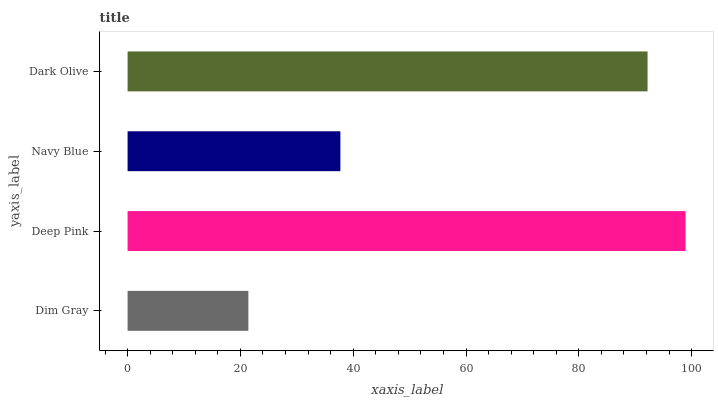Is Dim Gray the minimum?
Answer yes or no. Yes. Is Deep Pink the maximum?
Answer yes or no. Yes. Is Navy Blue the minimum?
Answer yes or no. No. Is Navy Blue the maximum?
Answer yes or no. No. Is Deep Pink greater than Navy Blue?
Answer yes or no. Yes. Is Navy Blue less than Deep Pink?
Answer yes or no. Yes. Is Navy Blue greater than Deep Pink?
Answer yes or no. No. Is Deep Pink less than Navy Blue?
Answer yes or no. No. Is Dark Olive the high median?
Answer yes or no. Yes. Is Navy Blue the low median?
Answer yes or no. Yes. Is Dim Gray the high median?
Answer yes or no. No. Is Dark Olive the low median?
Answer yes or no. No. 